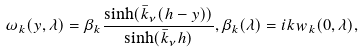<formula> <loc_0><loc_0><loc_500><loc_500>\omega _ { k } ( y , \lambda ) = \beta _ { k } \frac { \sinh ( \bar { k } _ { \nu } ( h - y ) ) } { \sinh ( \bar { k } _ { \nu } h ) } , \beta _ { k } ( \lambda ) = i k w _ { k } ( 0 , \lambda ) ,</formula> 